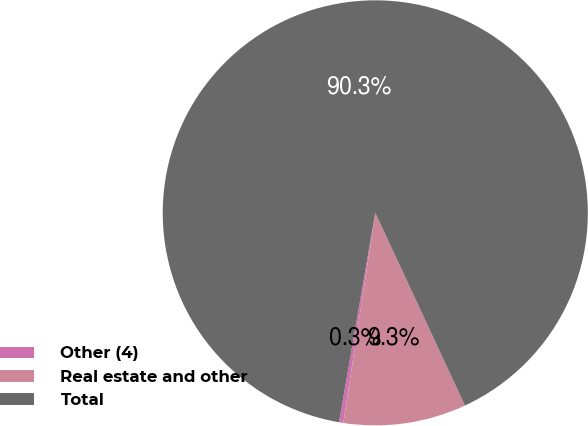<chart> <loc_0><loc_0><loc_500><loc_500><pie_chart><fcel>Other (4)<fcel>Real estate and other<fcel>Total<nl><fcel>0.33%<fcel>9.33%<fcel>90.33%<nl></chart> 